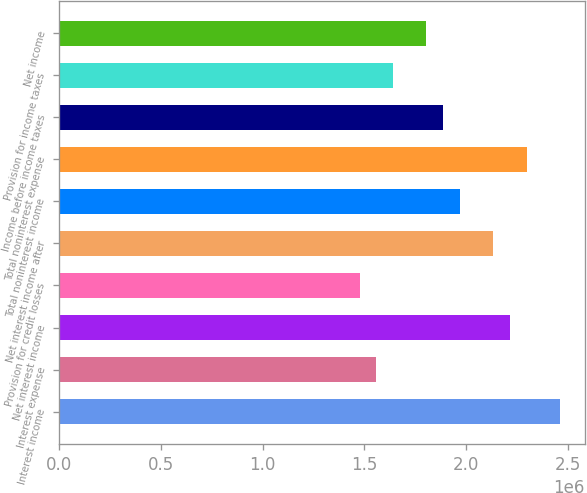Convert chart. <chart><loc_0><loc_0><loc_500><loc_500><bar_chart><fcel>Interest income<fcel>Interest expense<fcel>Net interest income<fcel>Provision for credit losses<fcel>Net interest income after<fcel>Total noninterest income<fcel>Total noninterest expense<fcel>Income before income taxes<fcel>Provision for income taxes<fcel>Net income<nl><fcel>2.46071e+06<fcel>1.55845e+06<fcel>2.21464e+06<fcel>1.47643e+06<fcel>2.13262e+06<fcel>1.96857e+06<fcel>2.29667e+06<fcel>1.88655e+06<fcel>1.64048e+06<fcel>1.80452e+06<nl></chart> 